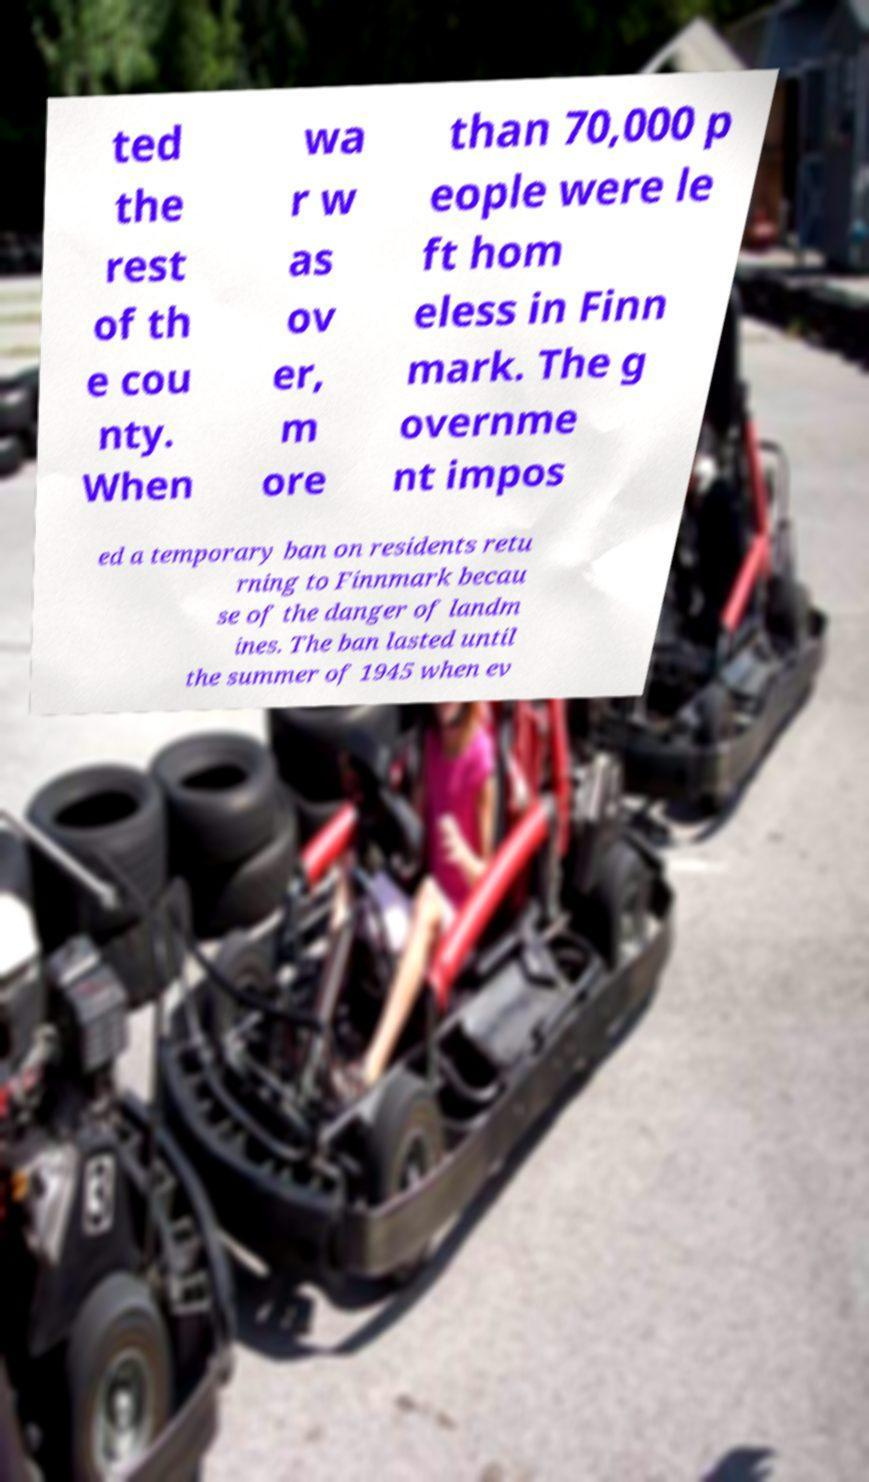Can you read and provide the text displayed in the image?This photo seems to have some interesting text. Can you extract and type it out for me? ted the rest of th e cou nty. When wa r w as ov er, m ore than 70,000 p eople were le ft hom eless in Finn mark. The g overnme nt impos ed a temporary ban on residents retu rning to Finnmark becau se of the danger of landm ines. The ban lasted until the summer of 1945 when ev 